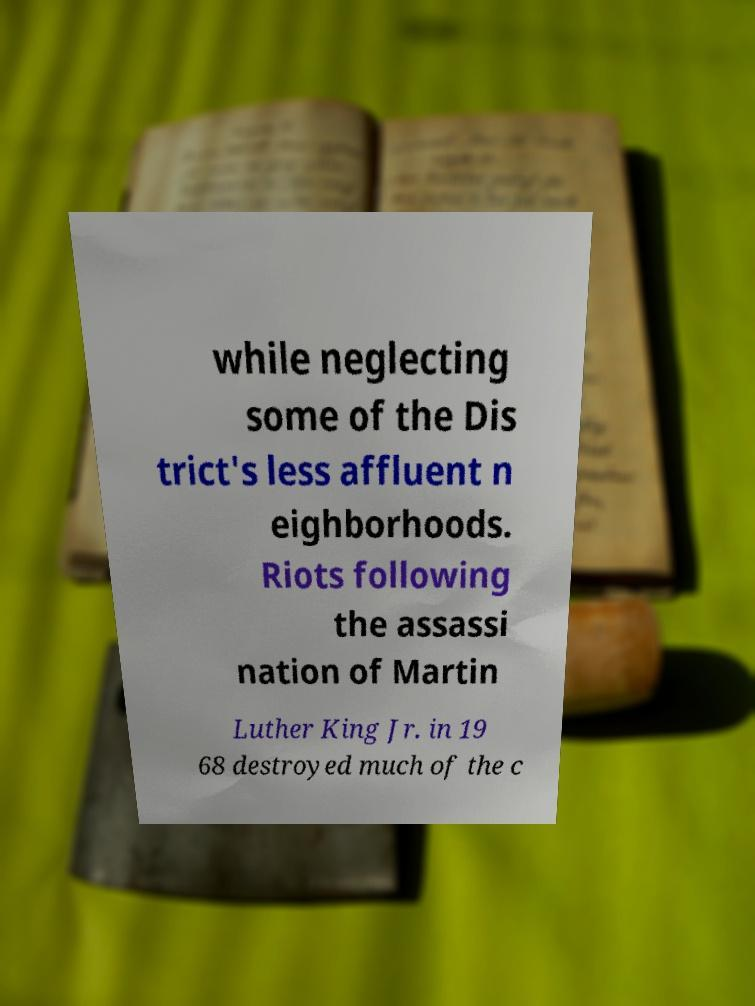For documentation purposes, I need the text within this image transcribed. Could you provide that? while neglecting some of the Dis trict's less affluent n eighborhoods. Riots following the assassi nation of Martin Luther King Jr. in 19 68 destroyed much of the c 